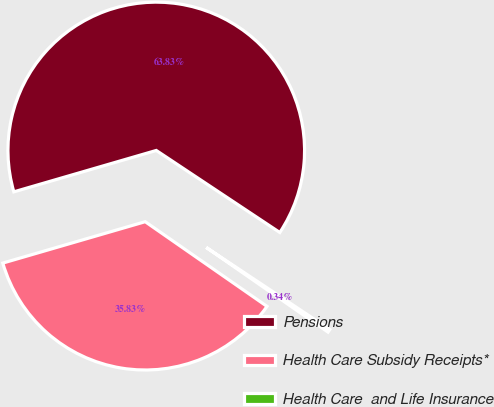<chart> <loc_0><loc_0><loc_500><loc_500><pie_chart><fcel>Pensions<fcel>Health Care Subsidy Receipts*<fcel>Health Care  and Life Insurance<nl><fcel>63.83%<fcel>35.83%<fcel>0.34%<nl></chart> 